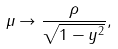Convert formula to latex. <formula><loc_0><loc_0><loc_500><loc_500>\mu \rightarrow \frac { \rho } { \sqrt { 1 - y ^ { 2 } } } ,</formula> 